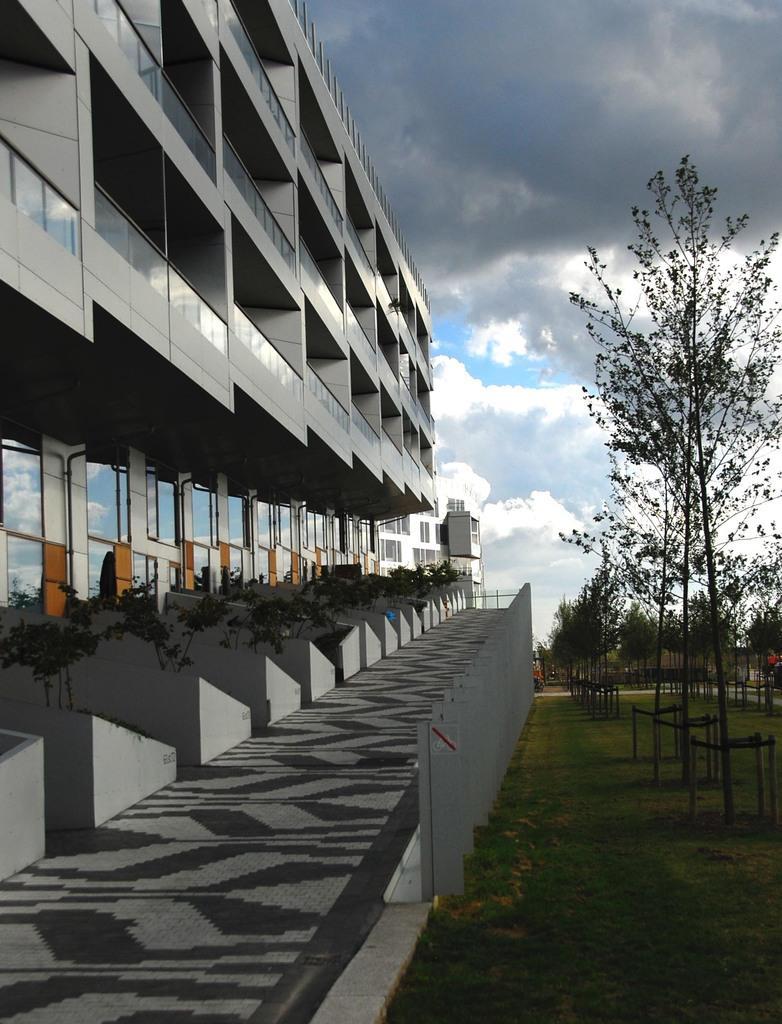Can you describe this image briefly? In this image we can see a few buildings, there are some plants, trees, grass and the wall, in the background we can see the sky with clouds. 